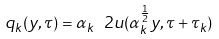<formula> <loc_0><loc_0><loc_500><loc_500>q _ { k } ( y , \tau ) = \alpha _ { k } \ 2 { u } ( \alpha _ { k } ^ { \frac { 1 } { 2 } } y , \tau + \tau _ { k } )</formula> 